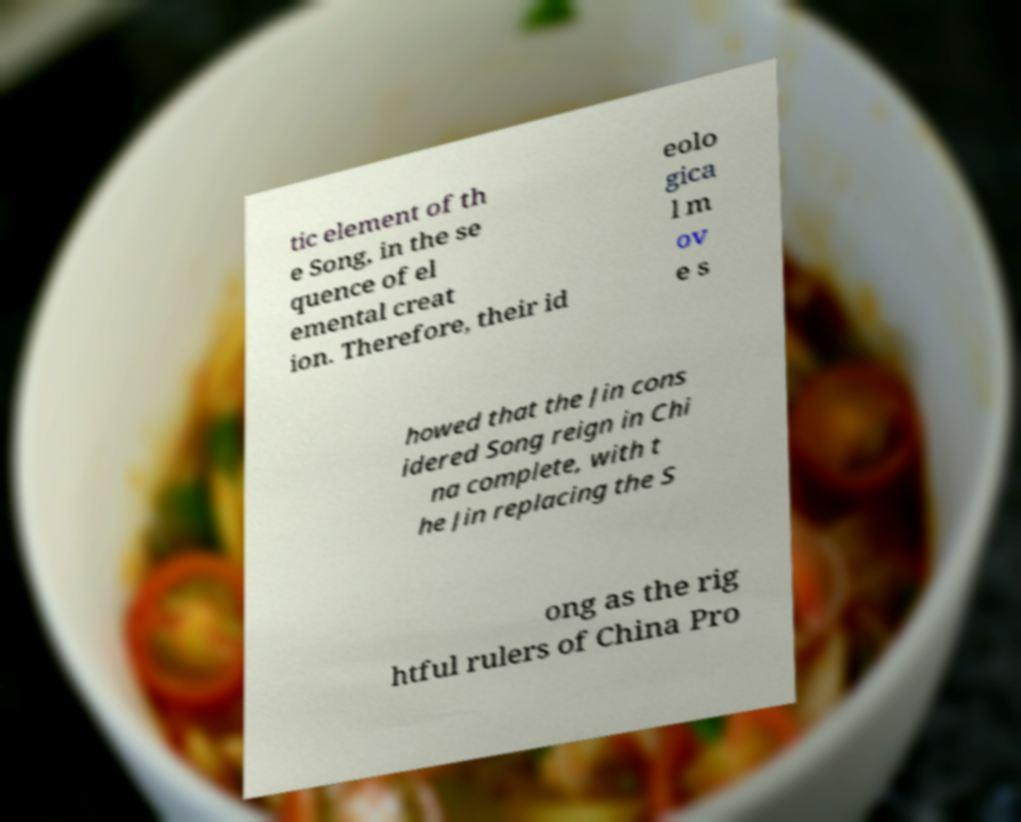Please read and relay the text visible in this image. What does it say? tic element of th e Song, in the se quence of el emental creat ion. Therefore, their id eolo gica l m ov e s howed that the Jin cons idered Song reign in Chi na complete, with t he Jin replacing the S ong as the rig htful rulers of China Pro 